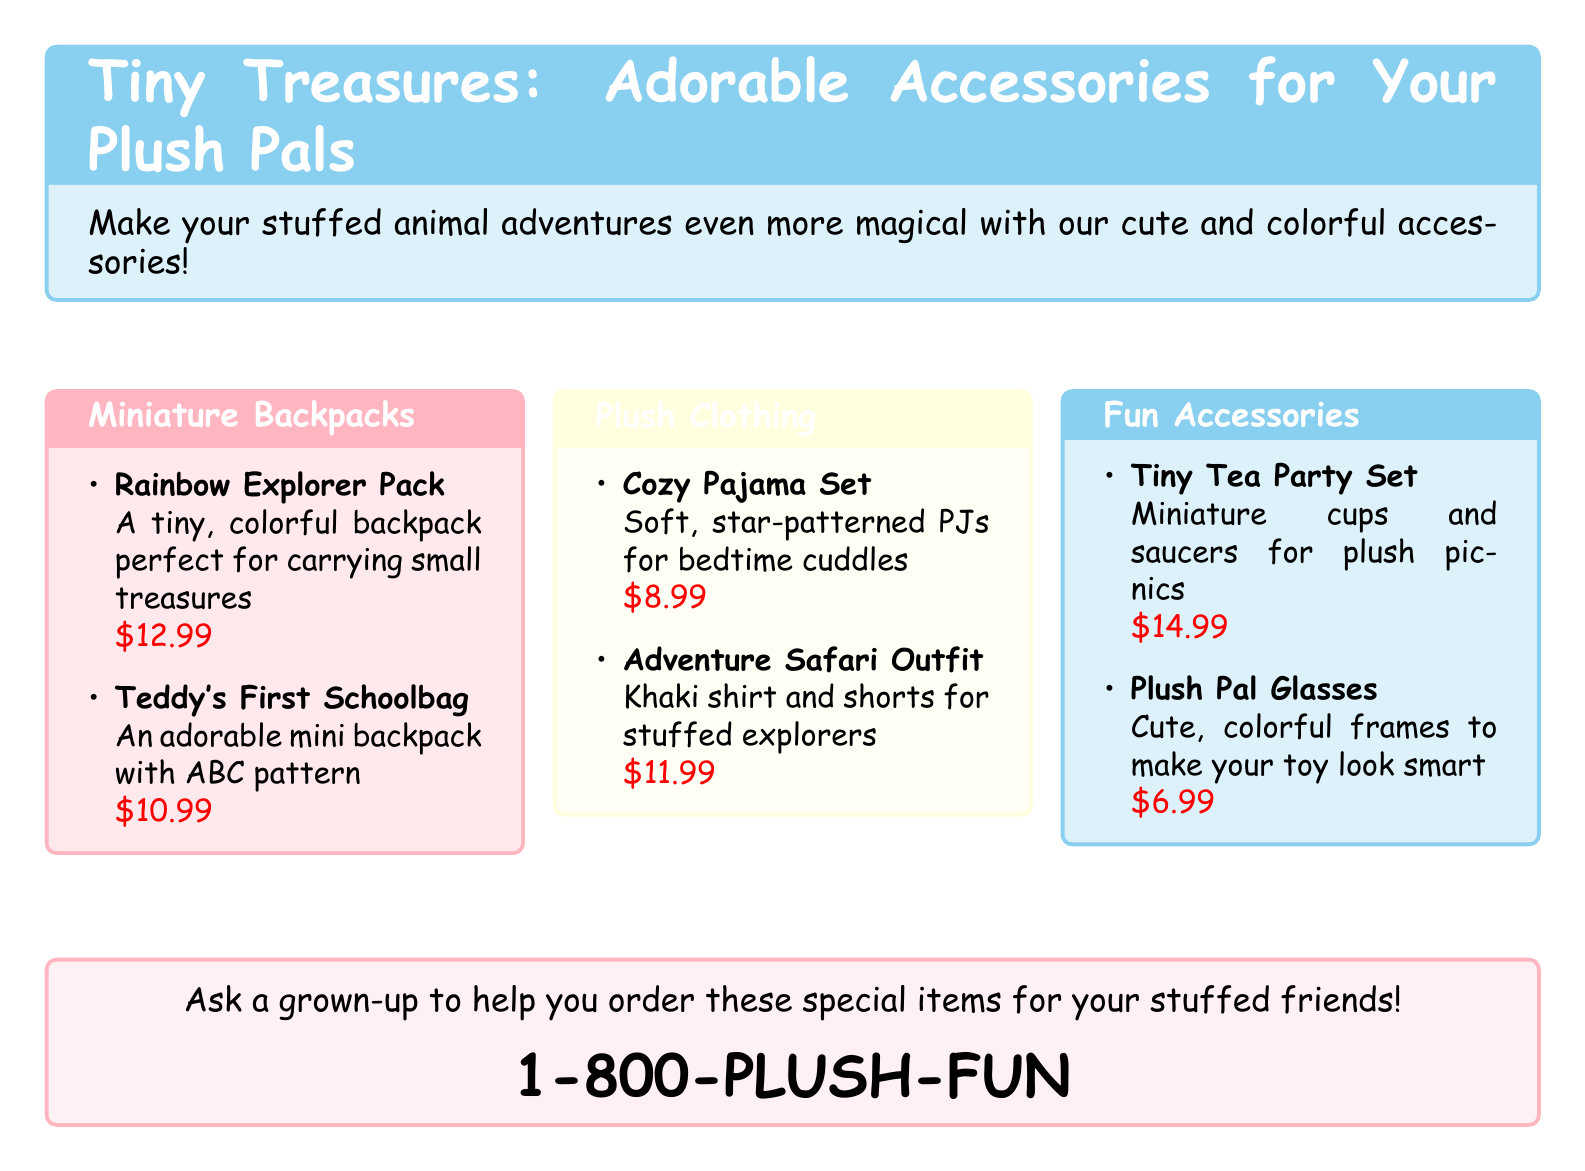What is the title of the catalog? The title is provided in a tcolorbox at the top of the document, which introduces the catalog's theme.
Answer: Tiny Treasures: Adorable Accessories for Your Plush Pals How much is the Rainbow Explorer Pack? The price is listed next to the item description in the backpack section of the catalog.
Answer: $12.99 What clothing item is designed for bedtime? The clothing section features various items, and one is specifically mentioned for bedtime use.
Answer: Cozy Pajama Set How many items are listed in the Fun Accessories section? The number of items can be counted directly from the Fun Accessories tcolorbox in the document.
Answer: 2 What is the price of the Plush Pal Glasses? The price is given right next to the item description in the Fun Accessories section.
Answer: $6.99 Which outfit is meant for explorers? This requires linking the description to the appropriate clothing item listed in the document.
Answer: Adventure Safari Outfit Is there a mini backpack that features an ABC pattern? This can be directly retrieved from the item descriptions under the Miniature Backpacks heading.
Answer: Teddy's First Schoolbag What phone number can you call to order items? The catalog provides a specific phone number at the bottom for customer inquiries.
Answer: 1-800-PLUSH-FUN 